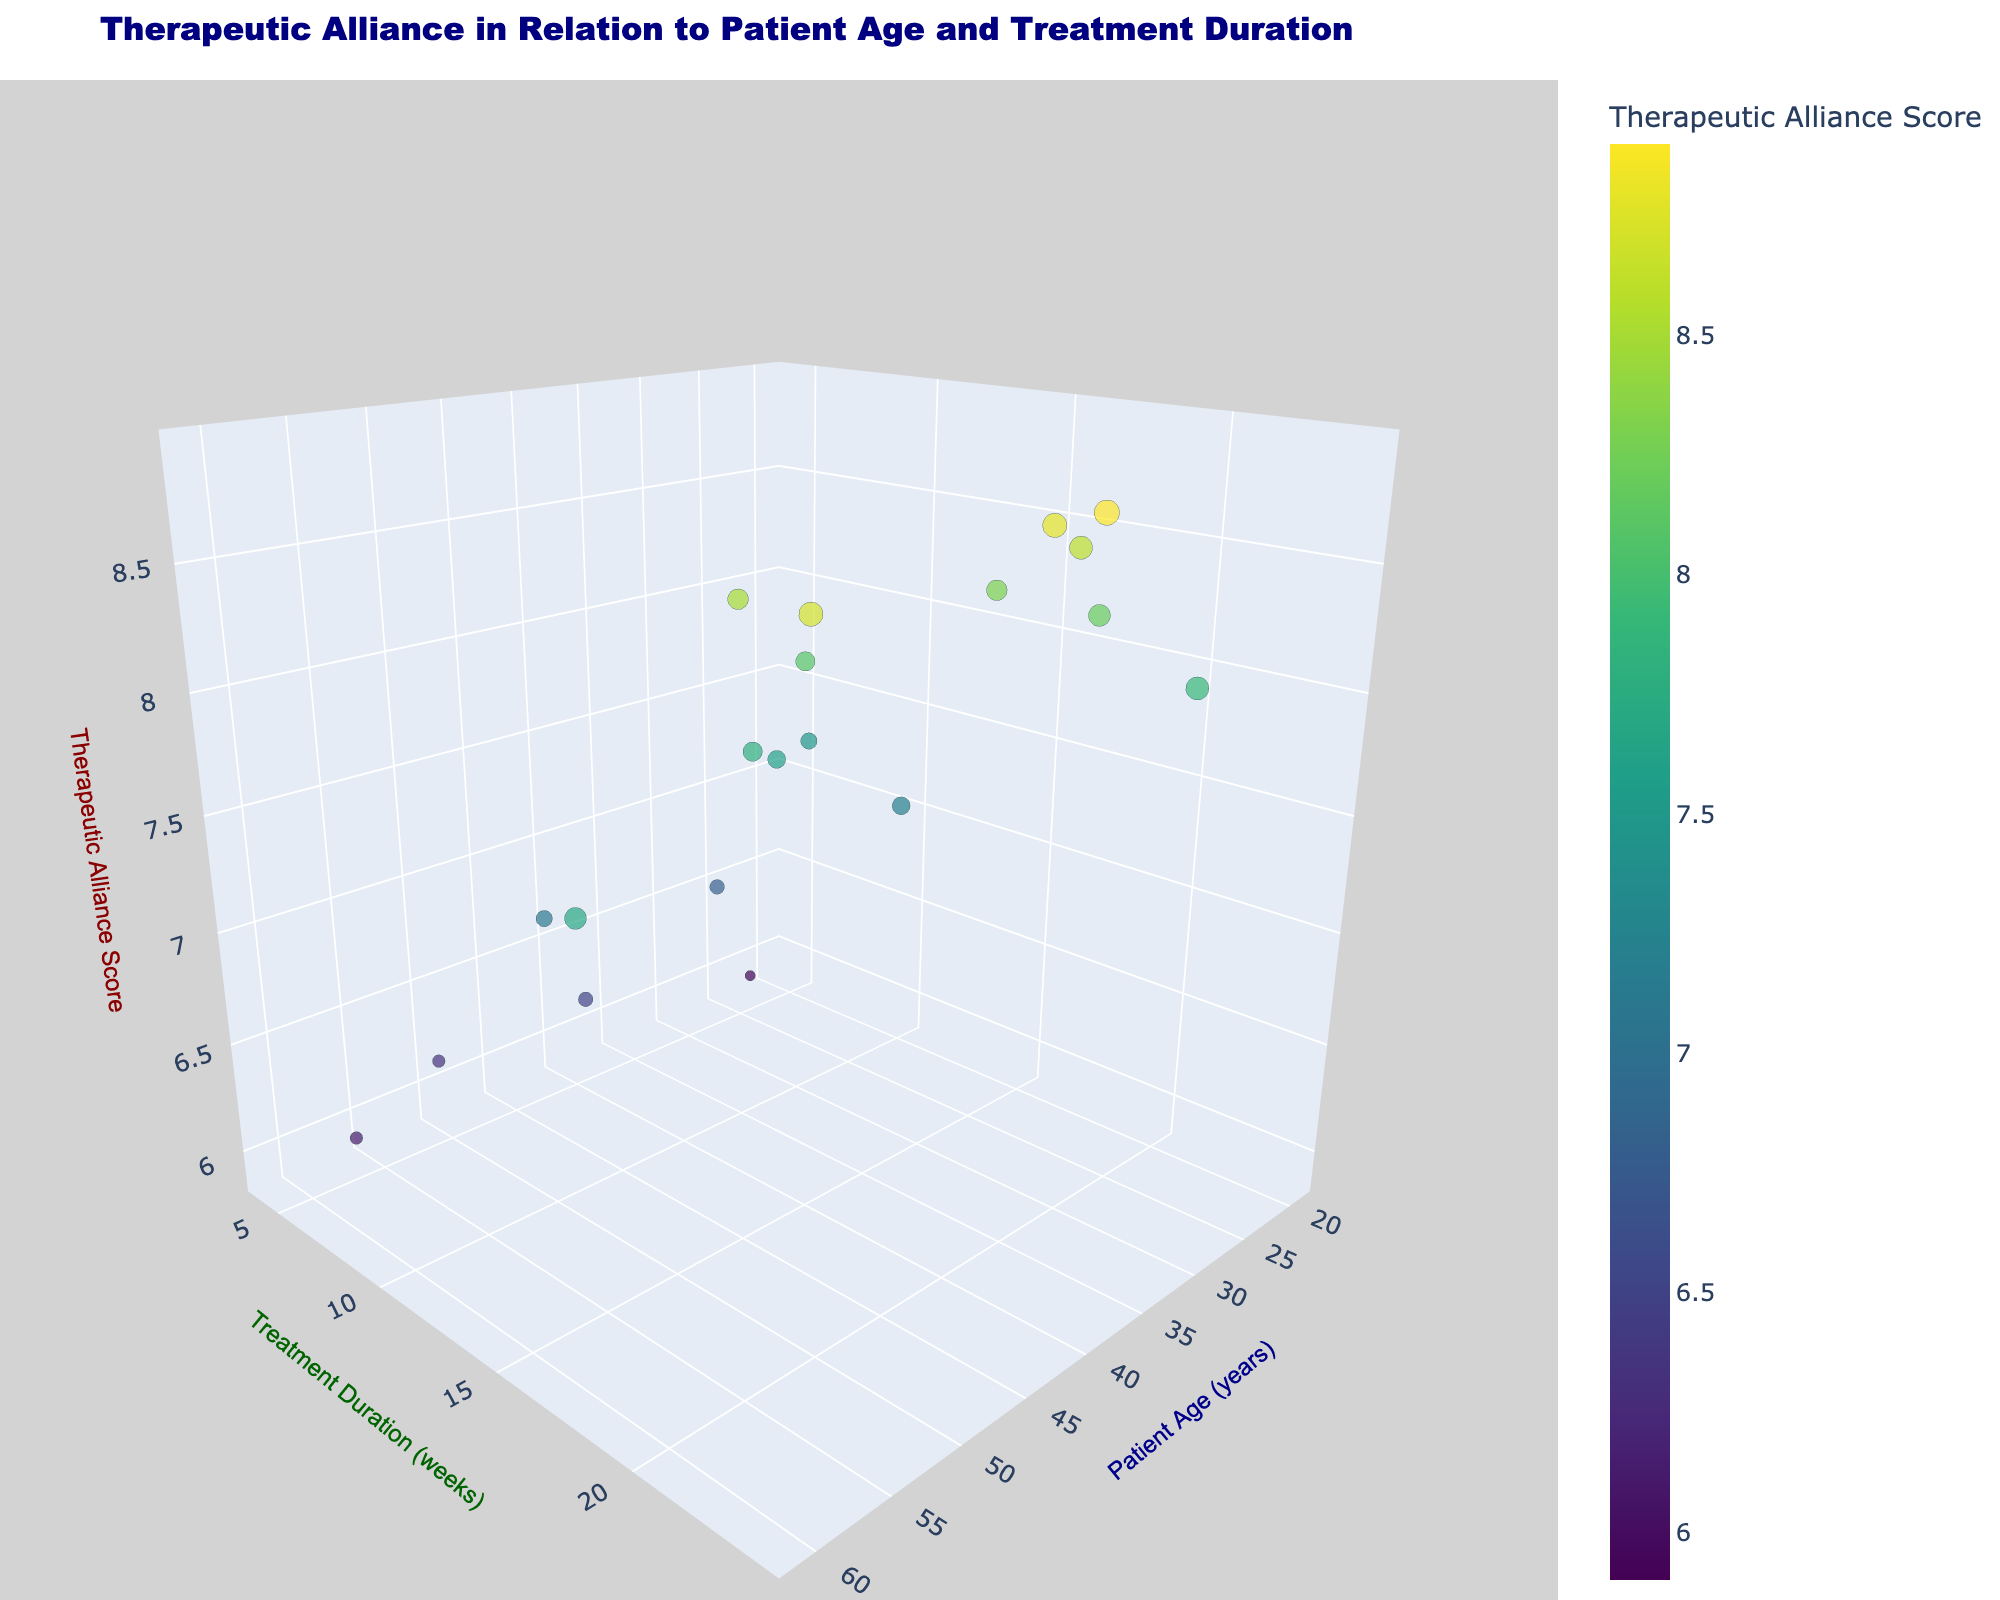What is the color scale used in the figure? The color scale used in the figure is 'Viridis', which is a color scale ranging from dark blue to yellow-green.
Answer: Viridis Where do you find the title of the figure? The title of the figure is found at the top center of the figure and reads "Therapeutic Alliance in Relation to Patient Age and Treatment Duration".
Answer: At the top center Which axis represents Patient Age? The x-axis represents Patient Age, as indicated by the label "Patient Age (years)".
Answer: x-axis What is the age range of patients in the dataset? Observing the x-axis, the patient ages range from 19 to 61 years.
Answer: 19 to 61 years How many data points indicate a Treatment Duration of 10 weeks? There are two data points that indicate a Treatment Duration of 10 weeks, as seen on the y-axis.
Answer: 2 Which patient age has the highest Therapeutic Alliance Score, and what is the score? The highest Therapeutic Alliance Score is 8.9, and it is achieved by a patient aged 41.
Answer: 41 and 8.9 What is the median value for the Therapeutic Alliance Score in the dataset? To find the median, arrange the scores in ascending order (5.9, 6.1, 6.3, 6.5, 6.8, 7.1, 7.2, 7.5, 7.6, 7.7, 7.8, 7.9, 8.1, 8.2, 8.3, 8.5, 8.6, 8.7, 8.8, 8.9). The median value is the middle one, which is 7.7.
Answer: 7.7 How does treatment duration correlate with the Therapeutic Alliance Score for patients aged above 50? For patients aged above 50, there is no consistent correlation since different durations (6, 18, and 22 weeks) lead to various scores (6.1, 6.3, 7.7, 8.7).
Answer: No consistent correlation Between which ages do you observe the highest variation in Therapeutic Alliance Scores? The highest variation in Therapeutic Alliance Scores appears between ages 31 to 41, ranging from 7.2 to 8.9.
Answer: 31 to 41 Is there a general trend observed between patient age and Therapeutic Alliance Score, and what is it? From visual observation, older patients generally have varying scores but tend to cluster around higher scores while younger patients show more variability.
Answer: Older patients cluster around higher scores 